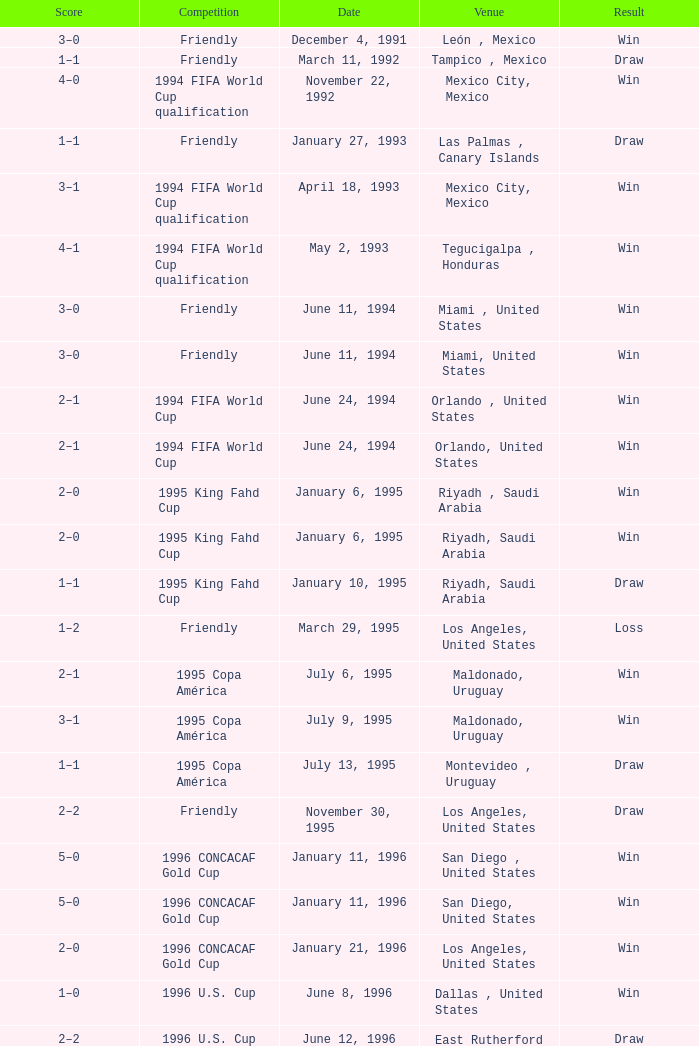What is Score, when Date is "June 8, 1996"? 1–0. 